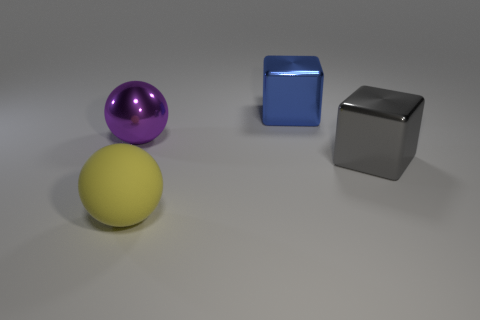Add 2 yellow balls. How many objects exist? 6 Subtract all purple balls. How many balls are left? 1 Subtract 1 spheres. How many spheres are left? 1 Subtract all purple spheres. Subtract all blue objects. How many objects are left? 2 Add 4 large blue metal blocks. How many large blue metal blocks are left? 5 Add 4 cyan matte balls. How many cyan matte balls exist? 4 Subtract 0 blue spheres. How many objects are left? 4 Subtract all gray cubes. Subtract all cyan cylinders. How many cubes are left? 1 Subtract all gray blocks. How many yellow balls are left? 1 